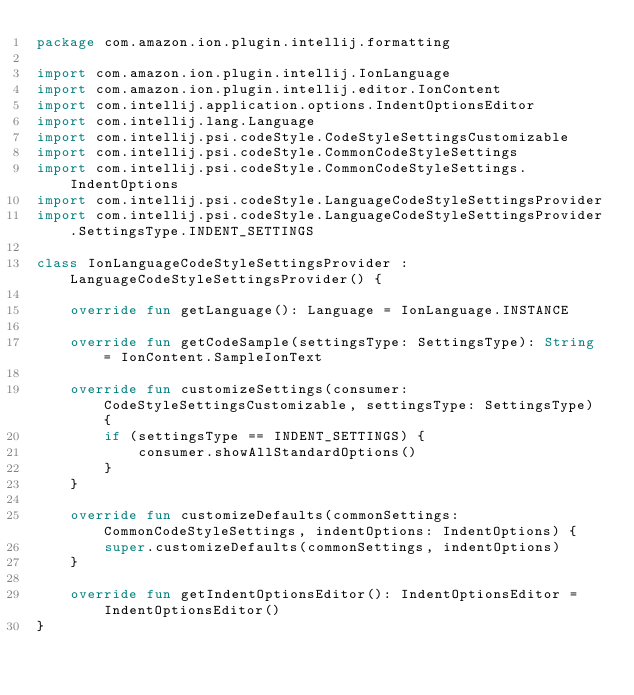Convert code to text. <code><loc_0><loc_0><loc_500><loc_500><_Kotlin_>package com.amazon.ion.plugin.intellij.formatting

import com.amazon.ion.plugin.intellij.IonLanguage
import com.amazon.ion.plugin.intellij.editor.IonContent
import com.intellij.application.options.IndentOptionsEditor
import com.intellij.lang.Language
import com.intellij.psi.codeStyle.CodeStyleSettingsCustomizable
import com.intellij.psi.codeStyle.CommonCodeStyleSettings
import com.intellij.psi.codeStyle.CommonCodeStyleSettings.IndentOptions
import com.intellij.psi.codeStyle.LanguageCodeStyleSettingsProvider
import com.intellij.psi.codeStyle.LanguageCodeStyleSettingsProvider.SettingsType.INDENT_SETTINGS

class IonLanguageCodeStyleSettingsProvider : LanguageCodeStyleSettingsProvider() {

    override fun getLanguage(): Language = IonLanguage.INSTANCE

    override fun getCodeSample(settingsType: SettingsType): String = IonContent.SampleIonText

    override fun customizeSettings(consumer: CodeStyleSettingsCustomizable, settingsType: SettingsType) {
        if (settingsType == INDENT_SETTINGS) {
            consumer.showAllStandardOptions()
        }
    }

    override fun customizeDefaults(commonSettings: CommonCodeStyleSettings, indentOptions: IndentOptions) {
        super.customizeDefaults(commonSettings, indentOptions)
    }

    override fun getIndentOptionsEditor(): IndentOptionsEditor = IndentOptionsEditor()
}
</code> 